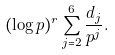<formula> <loc_0><loc_0><loc_500><loc_500>( \log { p } ) ^ { r } \sum _ { j = 2 } ^ { 6 } \frac { d _ { j } } { p ^ { j } } .</formula> 